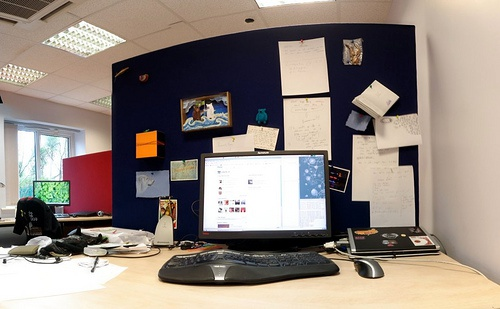Describe the objects in this image and their specific colors. I can see tv in gray, white, and black tones, keyboard in gray and black tones, laptop in gray, black, and darkgray tones, chair in gray, black, and darkgreen tones, and mouse in gray, black, white, and darkgray tones in this image. 